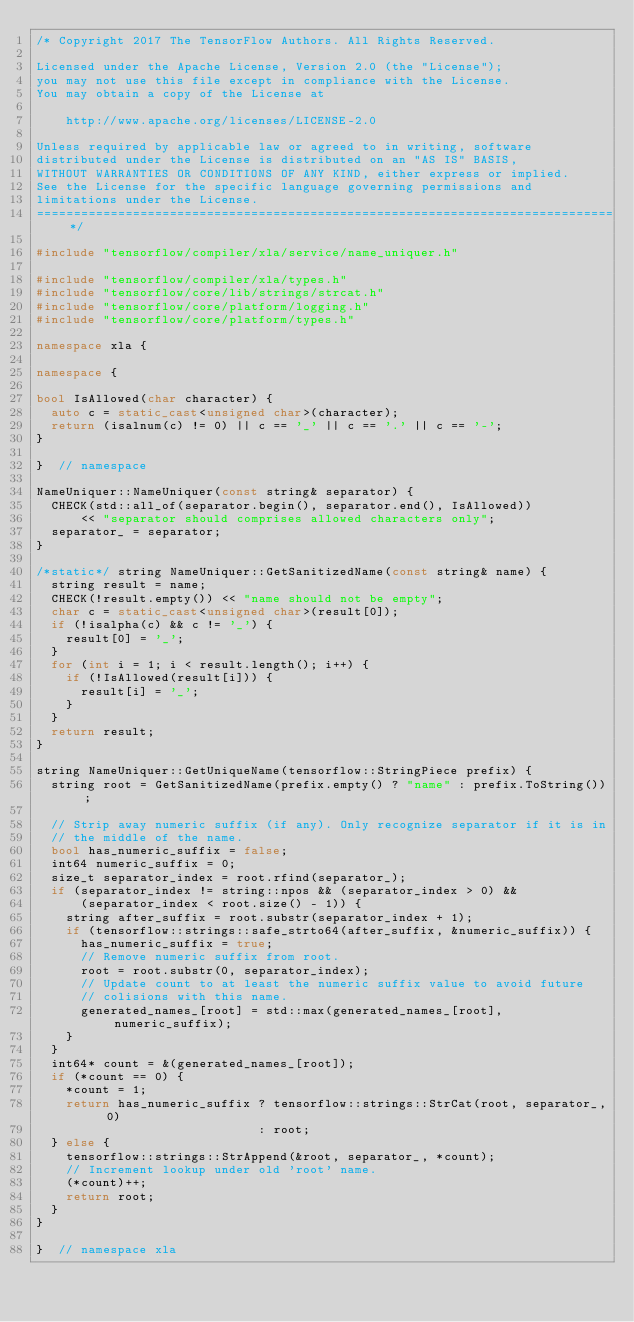Convert code to text. <code><loc_0><loc_0><loc_500><loc_500><_C++_>/* Copyright 2017 The TensorFlow Authors. All Rights Reserved.

Licensed under the Apache License, Version 2.0 (the "License");
you may not use this file except in compliance with the License.
You may obtain a copy of the License at

    http://www.apache.org/licenses/LICENSE-2.0

Unless required by applicable law or agreed to in writing, software
distributed under the License is distributed on an "AS IS" BASIS,
WITHOUT WARRANTIES OR CONDITIONS OF ANY KIND, either express or implied.
See the License for the specific language governing permissions and
limitations under the License.
==============================================================================*/

#include "tensorflow/compiler/xla/service/name_uniquer.h"

#include "tensorflow/compiler/xla/types.h"
#include "tensorflow/core/lib/strings/strcat.h"
#include "tensorflow/core/platform/logging.h"
#include "tensorflow/core/platform/types.h"

namespace xla {

namespace {

bool IsAllowed(char character) {
  auto c = static_cast<unsigned char>(character);
  return (isalnum(c) != 0) || c == '_' || c == '.' || c == '-';
}

}  // namespace

NameUniquer::NameUniquer(const string& separator) {
  CHECK(std::all_of(separator.begin(), separator.end(), IsAllowed))
      << "separator should comprises allowed characters only";
  separator_ = separator;
}

/*static*/ string NameUniquer::GetSanitizedName(const string& name) {
  string result = name;
  CHECK(!result.empty()) << "name should not be empty";
  char c = static_cast<unsigned char>(result[0]);
  if (!isalpha(c) && c != '_') {
    result[0] = '_';
  }
  for (int i = 1; i < result.length(); i++) {
    if (!IsAllowed(result[i])) {
      result[i] = '_';
    }
  }
  return result;
}

string NameUniquer::GetUniqueName(tensorflow::StringPiece prefix) {
  string root = GetSanitizedName(prefix.empty() ? "name" : prefix.ToString());

  // Strip away numeric suffix (if any). Only recognize separator if it is in
  // the middle of the name.
  bool has_numeric_suffix = false;
  int64 numeric_suffix = 0;
  size_t separator_index = root.rfind(separator_);
  if (separator_index != string::npos && (separator_index > 0) &&
      (separator_index < root.size() - 1)) {
    string after_suffix = root.substr(separator_index + 1);
    if (tensorflow::strings::safe_strto64(after_suffix, &numeric_suffix)) {
      has_numeric_suffix = true;
      // Remove numeric suffix from root.
      root = root.substr(0, separator_index);
      // Update count to at least the numeric suffix value to avoid future
      // colisions with this name.
      generated_names_[root] = std::max(generated_names_[root], numeric_suffix);
    }
  }
  int64* count = &(generated_names_[root]);
  if (*count == 0) {
    *count = 1;
    return has_numeric_suffix ? tensorflow::strings::StrCat(root, separator_, 0)
                              : root;
  } else {
    tensorflow::strings::StrAppend(&root, separator_, *count);
    // Increment lookup under old 'root' name.
    (*count)++;
    return root;
  }
}

}  // namespace xla
</code> 